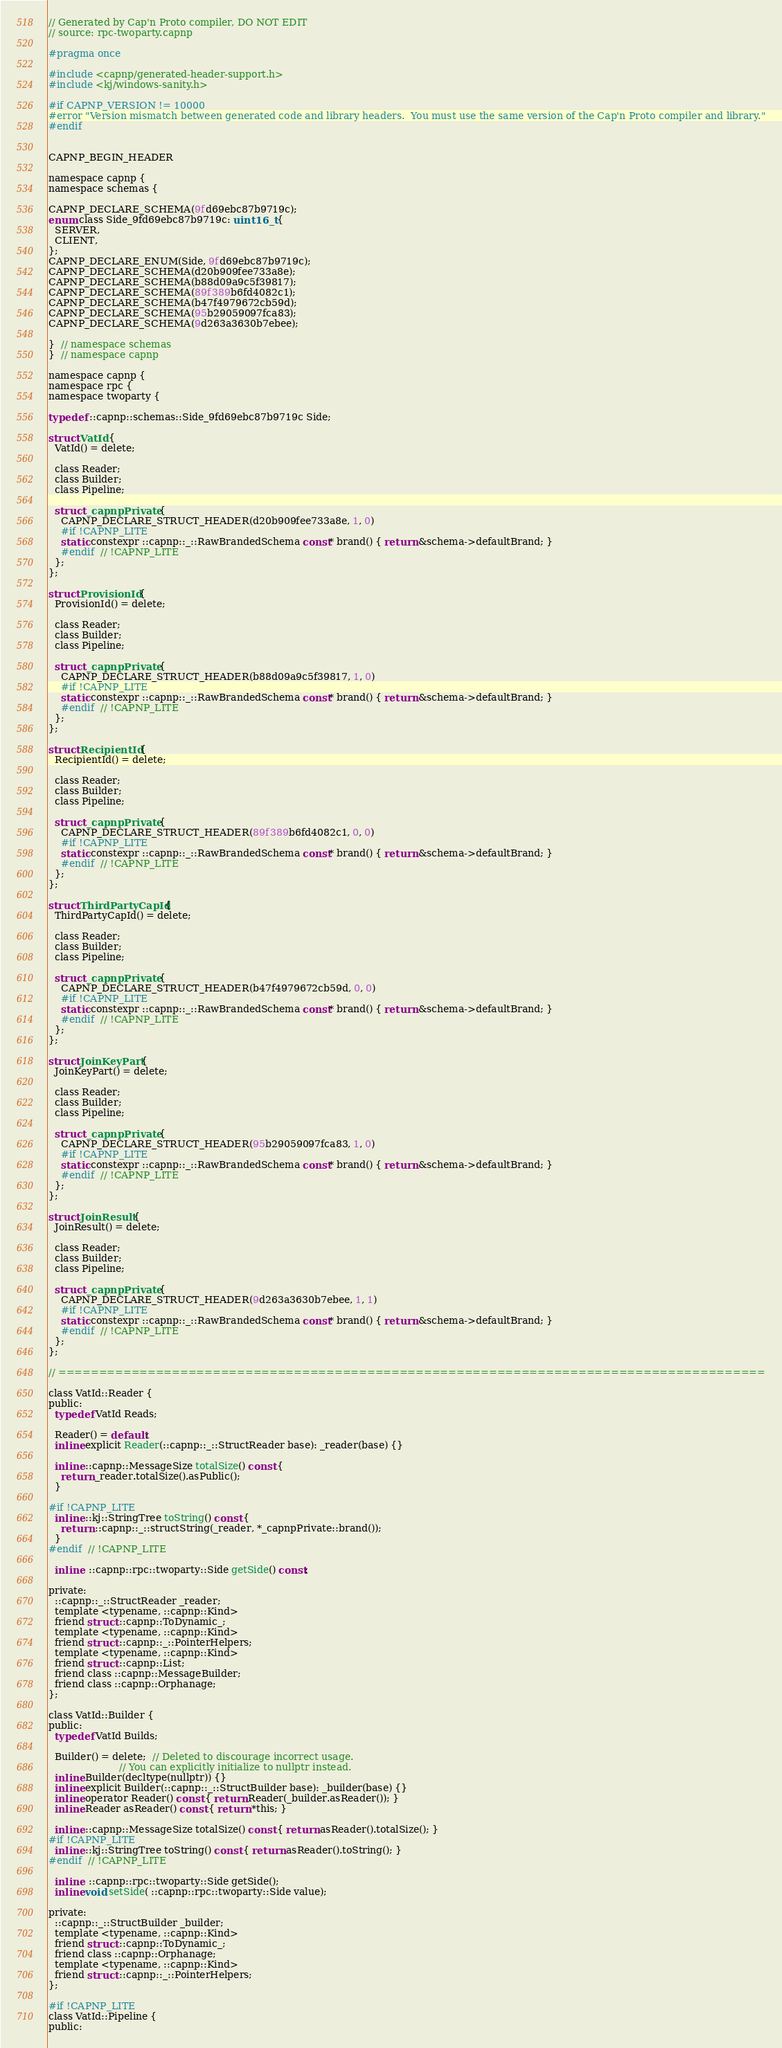Convert code to text. <code><loc_0><loc_0><loc_500><loc_500><_C_>// Generated by Cap'n Proto compiler, DO NOT EDIT
// source: rpc-twoparty.capnp

#pragma once

#include <capnp/generated-header-support.h>
#include <kj/windows-sanity.h>

#if CAPNP_VERSION != 10000
#error "Version mismatch between generated code and library headers.  You must use the same version of the Cap'n Proto compiler and library."
#endif


CAPNP_BEGIN_HEADER

namespace capnp {
namespace schemas {

CAPNP_DECLARE_SCHEMA(9fd69ebc87b9719c);
enum class Side_9fd69ebc87b9719c: uint16_t {
  SERVER,
  CLIENT,
};
CAPNP_DECLARE_ENUM(Side, 9fd69ebc87b9719c);
CAPNP_DECLARE_SCHEMA(d20b909fee733a8e);
CAPNP_DECLARE_SCHEMA(b88d09a9c5f39817);
CAPNP_DECLARE_SCHEMA(89f389b6fd4082c1);
CAPNP_DECLARE_SCHEMA(b47f4979672cb59d);
CAPNP_DECLARE_SCHEMA(95b29059097fca83);
CAPNP_DECLARE_SCHEMA(9d263a3630b7ebee);

}  // namespace schemas
}  // namespace capnp

namespace capnp {
namespace rpc {
namespace twoparty {

typedef ::capnp::schemas::Side_9fd69ebc87b9719c Side;

struct VatId {
  VatId() = delete;

  class Reader;
  class Builder;
  class Pipeline;

  struct _capnpPrivate {
    CAPNP_DECLARE_STRUCT_HEADER(d20b909fee733a8e, 1, 0)
    #if !CAPNP_LITE
    static constexpr ::capnp::_::RawBrandedSchema const* brand() { return &schema->defaultBrand; }
    #endif  // !CAPNP_LITE
  };
};

struct ProvisionId {
  ProvisionId() = delete;

  class Reader;
  class Builder;
  class Pipeline;

  struct _capnpPrivate {
    CAPNP_DECLARE_STRUCT_HEADER(b88d09a9c5f39817, 1, 0)
    #if !CAPNP_LITE
    static constexpr ::capnp::_::RawBrandedSchema const* brand() { return &schema->defaultBrand; }
    #endif  // !CAPNP_LITE
  };
};

struct RecipientId {
  RecipientId() = delete;

  class Reader;
  class Builder;
  class Pipeline;

  struct _capnpPrivate {
    CAPNP_DECLARE_STRUCT_HEADER(89f389b6fd4082c1, 0, 0)
    #if !CAPNP_LITE
    static constexpr ::capnp::_::RawBrandedSchema const* brand() { return &schema->defaultBrand; }
    #endif  // !CAPNP_LITE
  };
};

struct ThirdPartyCapId {
  ThirdPartyCapId() = delete;

  class Reader;
  class Builder;
  class Pipeline;

  struct _capnpPrivate {
    CAPNP_DECLARE_STRUCT_HEADER(b47f4979672cb59d, 0, 0)
    #if !CAPNP_LITE
    static constexpr ::capnp::_::RawBrandedSchema const* brand() { return &schema->defaultBrand; }
    #endif  // !CAPNP_LITE
  };
};

struct JoinKeyPart {
  JoinKeyPart() = delete;

  class Reader;
  class Builder;
  class Pipeline;

  struct _capnpPrivate {
    CAPNP_DECLARE_STRUCT_HEADER(95b29059097fca83, 1, 0)
    #if !CAPNP_LITE
    static constexpr ::capnp::_::RawBrandedSchema const* brand() { return &schema->defaultBrand; }
    #endif  // !CAPNP_LITE
  };
};

struct JoinResult {
  JoinResult() = delete;

  class Reader;
  class Builder;
  class Pipeline;

  struct _capnpPrivate {
    CAPNP_DECLARE_STRUCT_HEADER(9d263a3630b7ebee, 1, 1)
    #if !CAPNP_LITE
    static constexpr ::capnp::_::RawBrandedSchema const* brand() { return &schema->defaultBrand; }
    #endif  // !CAPNP_LITE
  };
};

// =======================================================================================

class VatId::Reader {
public:
  typedef VatId Reads;

  Reader() = default;
  inline explicit Reader(::capnp::_::StructReader base): _reader(base) {}

  inline ::capnp::MessageSize totalSize() const {
    return _reader.totalSize().asPublic();
  }

#if !CAPNP_LITE
  inline ::kj::StringTree toString() const {
    return ::capnp::_::structString(_reader, *_capnpPrivate::brand());
  }
#endif  // !CAPNP_LITE

  inline  ::capnp::rpc::twoparty::Side getSide() const;

private:
  ::capnp::_::StructReader _reader;
  template <typename, ::capnp::Kind>
  friend struct ::capnp::ToDynamic_;
  template <typename, ::capnp::Kind>
  friend struct ::capnp::_::PointerHelpers;
  template <typename, ::capnp::Kind>
  friend struct ::capnp::List;
  friend class ::capnp::MessageBuilder;
  friend class ::capnp::Orphanage;
};

class VatId::Builder {
public:
  typedef VatId Builds;

  Builder() = delete;  // Deleted to discourage incorrect usage.
                       // You can explicitly initialize to nullptr instead.
  inline Builder(decltype(nullptr)) {}
  inline explicit Builder(::capnp::_::StructBuilder base): _builder(base) {}
  inline operator Reader() const { return Reader(_builder.asReader()); }
  inline Reader asReader() const { return *this; }

  inline ::capnp::MessageSize totalSize() const { return asReader().totalSize(); }
#if !CAPNP_LITE
  inline ::kj::StringTree toString() const { return asReader().toString(); }
#endif  // !CAPNP_LITE

  inline  ::capnp::rpc::twoparty::Side getSide();
  inline void setSide( ::capnp::rpc::twoparty::Side value);

private:
  ::capnp::_::StructBuilder _builder;
  template <typename, ::capnp::Kind>
  friend struct ::capnp::ToDynamic_;
  friend class ::capnp::Orphanage;
  template <typename, ::capnp::Kind>
  friend struct ::capnp::_::PointerHelpers;
};

#if !CAPNP_LITE
class VatId::Pipeline {
public:</code> 